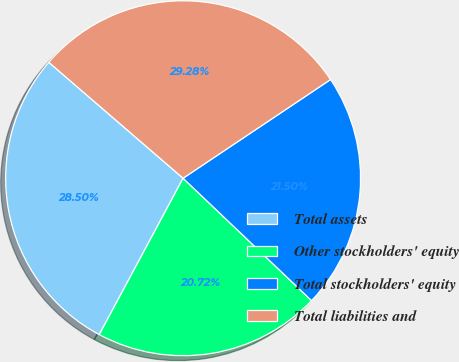Convert chart to OTSL. <chart><loc_0><loc_0><loc_500><loc_500><pie_chart><fcel>Total assets<fcel>Other stockholders' equity<fcel>Total stockholders' equity<fcel>Total liabilities and<nl><fcel>28.5%<fcel>20.72%<fcel>21.5%<fcel>29.28%<nl></chart> 